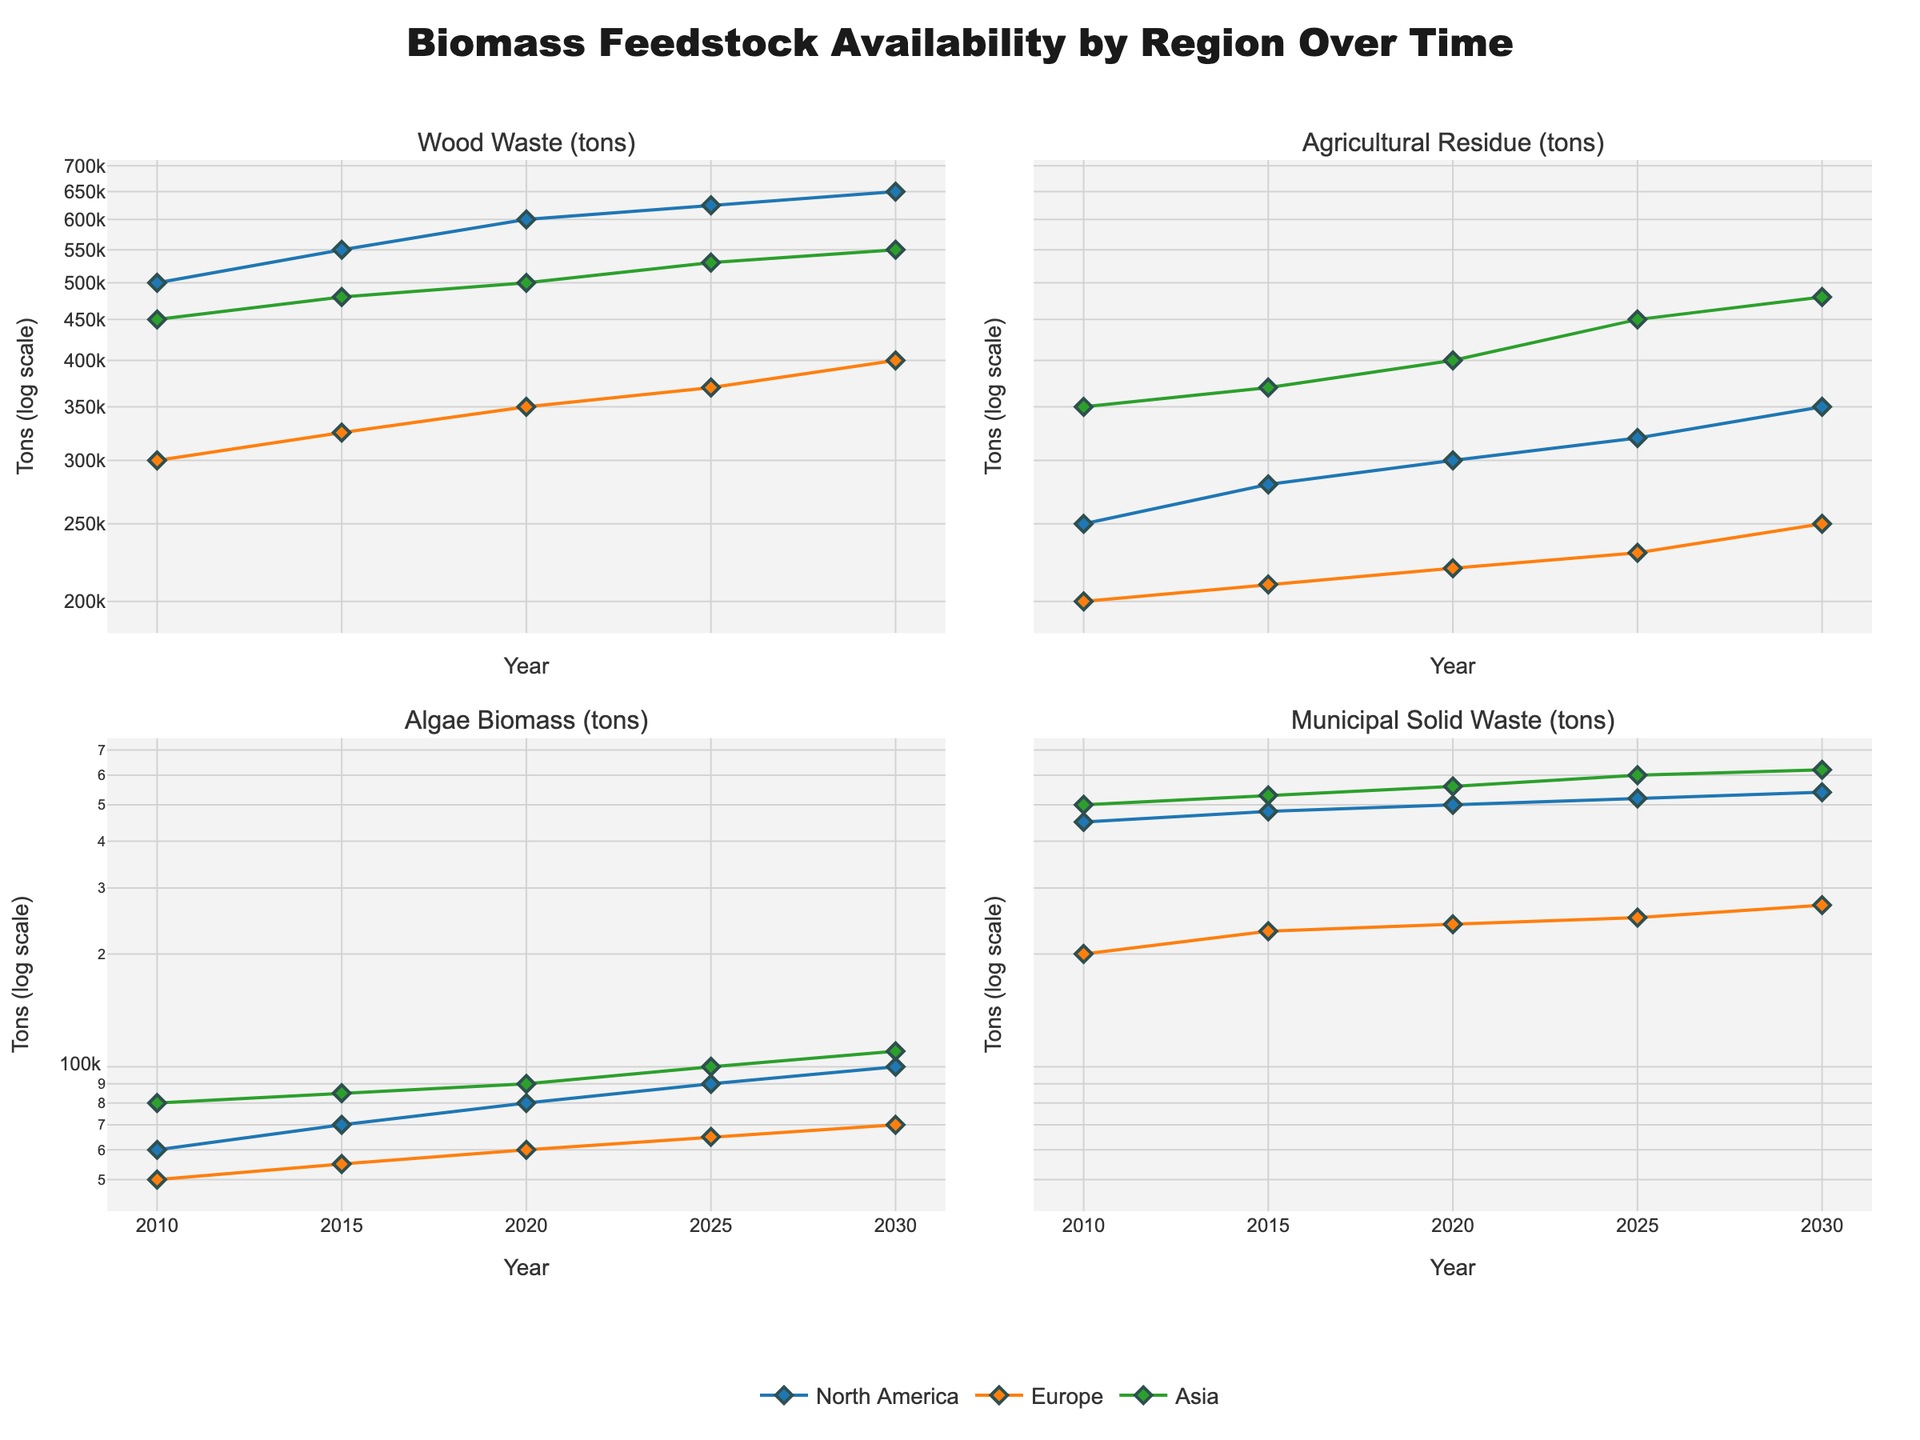What regions are represented in the figure? The figure displays data for three regions: North America, Europe, and Asia. Each region is represented by distinct colors in the plots.
Answer: North America, Europe, Asia What does the y-axis represent, and what is unique about it? The y-axis represents the biomass feedstock availability measured in tons. The unique aspect is that it uses a logarithmic scale, which helps in visualizing the data spanning several orders of magnitude.
Answer: Tons (log scale) Which type of biomass has the highest availability in 2030 in Asia? In 2030 for Asia, we need to compare the values for Wood Waste, Agricultural Residue, Algae Biomass, and Municipal Solid Waste. The plot indicates the highest value is for Municipal Solid Waste.
Answer: Municipal Solid Waste How did the availability of Wood Waste in North America change from 2015 to 2025? In 2015, the availability of Wood Waste in North America is 550,000 tons. By 2025, it has increased to 625,000 tons. The change is calculated by subtracting the 2015 value from the 2025 value, resulting in an increase of 75,000 tons.
Answer: Increased by 75,000 tons Compare the availability of Agricultural Residue in Europe and Asia in 2020. Which region has more, and by how much? In 2020, Europe has 220,000 tons of Agricultural Residue and Asia has 400,000 tons. Asia has more Agricultural Residue. The difference is 400,000 - 220,000 = 180,000 tons.
Answer: Asia, by 180,000 tons Which biomass type shows a steady increase across all regions from 2010 to 2030? By reviewing all plot lines for each biomass type, one can observe that all biomass types show a general increasing trend, but Wood Waste shows a consistent, steady increase across all regions from 2010 to 2030.
Answer: Wood Waste What can you infer about the trend of Algae Biomass availability in Europe from 2010 to 2030? In the plot for Algae Biomass, Europe's data points display a gradual increase from 2010 (50,000 tons) to 2030 (70,000 tons), indicating a positive trend over the years.
Answer: Increasing trend Which biomass type has the least variation in availability in North America over the entire period? By observing the plot for each biomass type in North America, Algae Biomass shows the least variation, maintaining values between 60,000 and 100,000 tons over the years.
Answer: Algae Biomass Has the Municipal Solid Waste availability in Asia shown any significant change from 2010 to 2020? From the plot, Municipal Solid Waste in Asia starts at 500,000 tons in 2010 and increases to 560,000 tons by 2020. The difference is 560,000 - 500,000 = 60,000 tons, which is a significant increase.
Answer: Yes, significant increase 